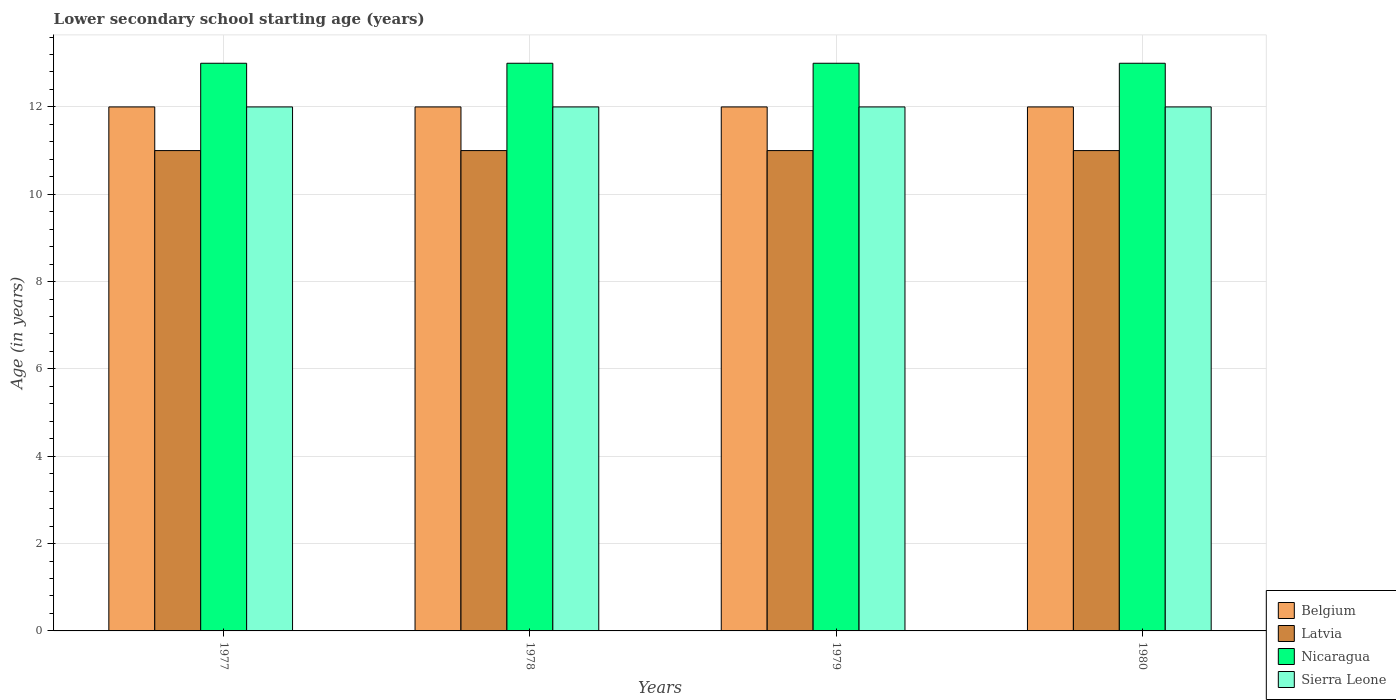Are the number of bars on each tick of the X-axis equal?
Offer a terse response. Yes. How many bars are there on the 1st tick from the right?
Ensure brevity in your answer.  4. What is the label of the 3rd group of bars from the left?
Your answer should be very brief. 1979. What is the lower secondary school starting age of children in Belgium in 1980?
Provide a short and direct response. 12. Across all years, what is the maximum lower secondary school starting age of children in Sierra Leone?
Make the answer very short. 12. Across all years, what is the minimum lower secondary school starting age of children in Sierra Leone?
Offer a very short reply. 12. In which year was the lower secondary school starting age of children in Belgium maximum?
Give a very brief answer. 1977. What is the total lower secondary school starting age of children in Sierra Leone in the graph?
Your answer should be compact. 48. What is the difference between the lower secondary school starting age of children in Latvia in 1979 and that in 1980?
Give a very brief answer. 0. What is the difference between the lower secondary school starting age of children in Belgium in 1977 and the lower secondary school starting age of children in Sierra Leone in 1978?
Provide a succinct answer. 0. In the year 1980, what is the difference between the lower secondary school starting age of children in Sierra Leone and lower secondary school starting age of children in Nicaragua?
Provide a short and direct response. -1. In how many years, is the lower secondary school starting age of children in Belgium greater than 12.8 years?
Offer a terse response. 0. Is the difference between the lower secondary school starting age of children in Sierra Leone in 1977 and 1978 greater than the difference between the lower secondary school starting age of children in Nicaragua in 1977 and 1978?
Keep it short and to the point. No. What is the difference between the highest and the second highest lower secondary school starting age of children in Sierra Leone?
Ensure brevity in your answer.  0. What is the difference between the highest and the lowest lower secondary school starting age of children in Nicaragua?
Offer a very short reply. 0. Is the sum of the lower secondary school starting age of children in Latvia in 1978 and 1980 greater than the maximum lower secondary school starting age of children in Nicaragua across all years?
Your answer should be compact. Yes. What does the 3rd bar from the left in 1977 represents?
Provide a short and direct response. Nicaragua. How many bars are there?
Offer a very short reply. 16. Are the values on the major ticks of Y-axis written in scientific E-notation?
Your answer should be very brief. No. Does the graph contain any zero values?
Provide a short and direct response. No. Where does the legend appear in the graph?
Make the answer very short. Bottom right. How many legend labels are there?
Provide a succinct answer. 4. What is the title of the graph?
Offer a very short reply. Lower secondary school starting age (years). Does "Bosnia and Herzegovina" appear as one of the legend labels in the graph?
Your response must be concise. No. What is the label or title of the Y-axis?
Provide a short and direct response. Age (in years). What is the Age (in years) in Latvia in 1978?
Provide a short and direct response. 11. What is the Age (in years) in Sierra Leone in 1978?
Offer a terse response. 12. What is the Age (in years) of Belgium in 1979?
Make the answer very short. 12. What is the Age (in years) in Latvia in 1979?
Give a very brief answer. 11. What is the Age (in years) in Nicaragua in 1979?
Give a very brief answer. 13. What is the Age (in years) in Sierra Leone in 1979?
Offer a very short reply. 12. What is the Age (in years) in Nicaragua in 1980?
Make the answer very short. 13. What is the Age (in years) of Sierra Leone in 1980?
Offer a terse response. 12. Across all years, what is the maximum Age (in years) of Latvia?
Your answer should be compact. 11. Across all years, what is the maximum Age (in years) of Nicaragua?
Offer a terse response. 13. Across all years, what is the maximum Age (in years) in Sierra Leone?
Provide a succinct answer. 12. Across all years, what is the minimum Age (in years) of Latvia?
Keep it short and to the point. 11. Across all years, what is the minimum Age (in years) in Nicaragua?
Offer a very short reply. 13. Across all years, what is the minimum Age (in years) in Sierra Leone?
Offer a terse response. 12. What is the total Age (in years) of Belgium in the graph?
Give a very brief answer. 48. What is the total Age (in years) of Sierra Leone in the graph?
Keep it short and to the point. 48. What is the difference between the Age (in years) of Belgium in 1977 and that in 1978?
Make the answer very short. 0. What is the difference between the Age (in years) in Latvia in 1977 and that in 1978?
Your response must be concise. 0. What is the difference between the Age (in years) of Nicaragua in 1977 and that in 1979?
Offer a very short reply. 0. What is the difference between the Age (in years) of Sierra Leone in 1977 and that in 1979?
Keep it short and to the point. 0. What is the difference between the Age (in years) of Belgium in 1977 and that in 1980?
Make the answer very short. 0. What is the difference between the Age (in years) in Nicaragua in 1977 and that in 1980?
Ensure brevity in your answer.  0. What is the difference between the Age (in years) in Sierra Leone in 1977 and that in 1980?
Make the answer very short. 0. What is the difference between the Age (in years) in Nicaragua in 1978 and that in 1979?
Your response must be concise. 0. What is the difference between the Age (in years) of Sierra Leone in 1978 and that in 1979?
Offer a terse response. 0. What is the difference between the Age (in years) of Latvia in 1978 and that in 1980?
Offer a terse response. 0. What is the difference between the Age (in years) of Nicaragua in 1978 and that in 1980?
Offer a terse response. 0. What is the difference between the Age (in years) of Sierra Leone in 1978 and that in 1980?
Give a very brief answer. 0. What is the difference between the Age (in years) in Belgium in 1979 and that in 1980?
Offer a terse response. 0. What is the difference between the Age (in years) in Belgium in 1977 and the Age (in years) in Latvia in 1978?
Your response must be concise. 1. What is the difference between the Age (in years) in Latvia in 1977 and the Age (in years) in Nicaragua in 1978?
Provide a succinct answer. -2. What is the difference between the Age (in years) in Nicaragua in 1977 and the Age (in years) in Sierra Leone in 1978?
Offer a terse response. 1. What is the difference between the Age (in years) of Belgium in 1977 and the Age (in years) of Latvia in 1979?
Make the answer very short. 1. What is the difference between the Age (in years) of Latvia in 1977 and the Age (in years) of Nicaragua in 1979?
Ensure brevity in your answer.  -2. What is the difference between the Age (in years) in Latvia in 1977 and the Age (in years) in Sierra Leone in 1979?
Make the answer very short. -1. What is the difference between the Age (in years) of Belgium in 1977 and the Age (in years) of Latvia in 1980?
Offer a terse response. 1. What is the difference between the Age (in years) in Belgium in 1977 and the Age (in years) in Nicaragua in 1980?
Your answer should be very brief. -1. What is the difference between the Age (in years) in Belgium in 1977 and the Age (in years) in Sierra Leone in 1980?
Provide a succinct answer. 0. What is the difference between the Age (in years) in Latvia in 1977 and the Age (in years) in Nicaragua in 1980?
Give a very brief answer. -2. What is the difference between the Age (in years) in Nicaragua in 1977 and the Age (in years) in Sierra Leone in 1980?
Your answer should be compact. 1. What is the difference between the Age (in years) of Nicaragua in 1978 and the Age (in years) of Sierra Leone in 1979?
Provide a short and direct response. 1. What is the difference between the Age (in years) in Belgium in 1978 and the Age (in years) in Latvia in 1980?
Your answer should be very brief. 1. What is the difference between the Age (in years) in Latvia in 1978 and the Age (in years) in Sierra Leone in 1980?
Give a very brief answer. -1. What is the difference between the Age (in years) in Nicaragua in 1978 and the Age (in years) in Sierra Leone in 1980?
Your answer should be very brief. 1. What is the difference between the Age (in years) of Belgium in 1979 and the Age (in years) of Sierra Leone in 1980?
Your response must be concise. 0. What is the average Age (in years) of Belgium per year?
Ensure brevity in your answer.  12. What is the average Age (in years) in Latvia per year?
Give a very brief answer. 11. What is the average Age (in years) of Nicaragua per year?
Provide a short and direct response. 13. In the year 1977, what is the difference between the Age (in years) in Belgium and Age (in years) in Sierra Leone?
Keep it short and to the point. 0. In the year 1978, what is the difference between the Age (in years) of Belgium and Age (in years) of Latvia?
Provide a succinct answer. 1. In the year 1978, what is the difference between the Age (in years) of Belgium and Age (in years) of Nicaragua?
Your answer should be compact. -1. In the year 1978, what is the difference between the Age (in years) of Belgium and Age (in years) of Sierra Leone?
Provide a short and direct response. 0. In the year 1978, what is the difference between the Age (in years) in Latvia and Age (in years) in Nicaragua?
Your answer should be very brief. -2. In the year 1979, what is the difference between the Age (in years) in Belgium and Age (in years) in Latvia?
Your answer should be compact. 1. In the year 1979, what is the difference between the Age (in years) in Nicaragua and Age (in years) in Sierra Leone?
Offer a very short reply. 1. In the year 1980, what is the difference between the Age (in years) in Belgium and Age (in years) in Nicaragua?
Your answer should be compact. -1. In the year 1980, what is the difference between the Age (in years) of Belgium and Age (in years) of Sierra Leone?
Offer a terse response. 0. In the year 1980, what is the difference between the Age (in years) in Latvia and Age (in years) in Nicaragua?
Provide a succinct answer. -2. What is the ratio of the Age (in years) of Belgium in 1977 to that in 1978?
Provide a succinct answer. 1. What is the ratio of the Age (in years) in Nicaragua in 1977 to that in 1978?
Offer a terse response. 1. What is the ratio of the Age (in years) of Latvia in 1977 to that in 1979?
Give a very brief answer. 1. What is the ratio of the Age (in years) of Nicaragua in 1977 to that in 1979?
Offer a terse response. 1. What is the ratio of the Age (in years) in Sierra Leone in 1977 to that in 1979?
Provide a succinct answer. 1. What is the ratio of the Age (in years) in Nicaragua in 1977 to that in 1980?
Your answer should be very brief. 1. What is the ratio of the Age (in years) in Sierra Leone in 1978 to that in 1979?
Give a very brief answer. 1. What is the ratio of the Age (in years) of Sierra Leone in 1978 to that in 1980?
Your answer should be compact. 1. What is the difference between the highest and the second highest Age (in years) in Nicaragua?
Your answer should be very brief. 0. What is the difference between the highest and the second highest Age (in years) of Sierra Leone?
Provide a short and direct response. 0. What is the difference between the highest and the lowest Age (in years) of Latvia?
Provide a succinct answer. 0. What is the difference between the highest and the lowest Age (in years) in Sierra Leone?
Provide a succinct answer. 0. 